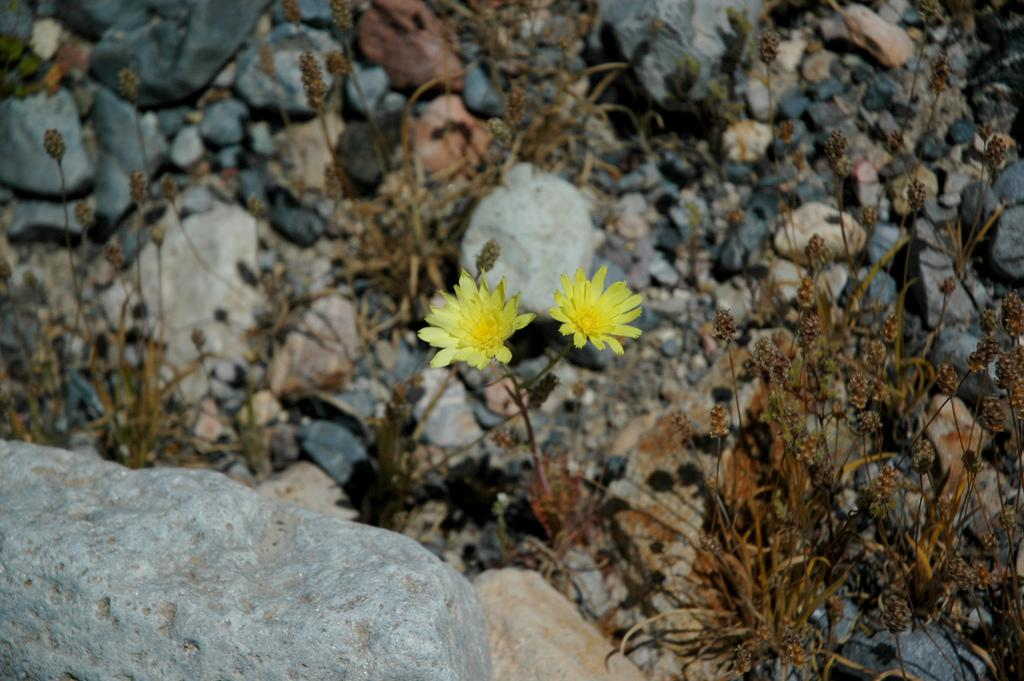How many flowers can be seen in the image? There are two flowers in the image. What else is present on the right side of the image? There is a plant on the right side of the image. What type of objects can be seen at the bottom of the image? Stones and rocks are visible at the bottom of the image. What type of lace is used to decorate the flowers in the image? There is no lace present in the image; it features two flowers and a plant. Who is the creator of the stones and rocks visible at the bottom of the image? The stones and rocks are natural formations and do not have a specific creator. 